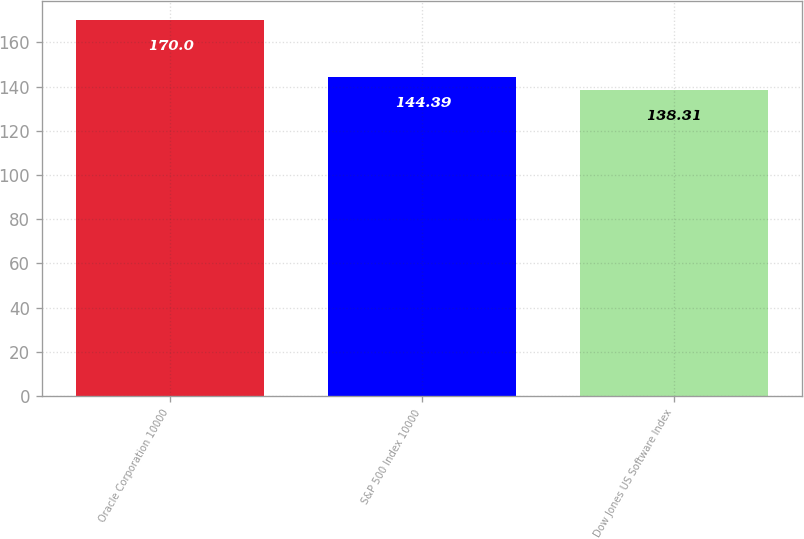<chart> <loc_0><loc_0><loc_500><loc_500><bar_chart><fcel>Oracle Corporation 10000<fcel>S&P 500 Index 10000<fcel>Dow Jones US Software Index<nl><fcel>170<fcel>144.39<fcel>138.31<nl></chart> 